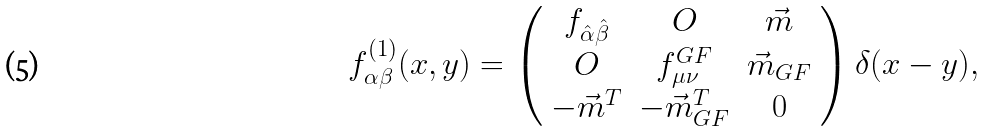<formula> <loc_0><loc_0><loc_500><loc_500>f ^ { ( 1 ) } _ { \alpha \beta } ( x , y ) = \left ( \begin{array} { c c c } f _ { \hat { \alpha } \hat { \beta } } & O & \vec { m } \\ O & f ^ { G F } _ { \mu \nu } & \vec { m } _ { G F } \\ - \vec { m } ^ { T } & - \vec { m } _ { G F } ^ { T } & 0 \end{array} \right ) \delta ( x - y ) ,</formula> 